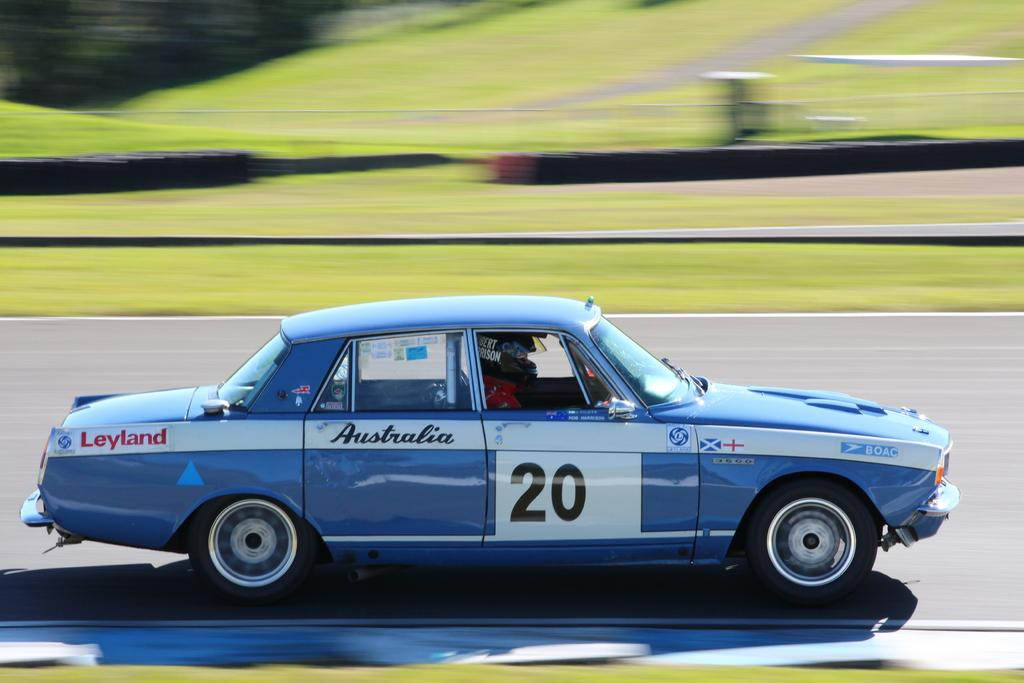What color is the car in the image? The car in the image is blue. Can you describe the person inside the car? A person is sitting inside the car. What can be observed about the background of the image? The background of the image is blurred. How many laborers are working on the car in the image? There are no laborers present in the image, and the car is not being worked on. What type of bubble can be seen floating near the car in the image? There are no bubbles present in the image. 